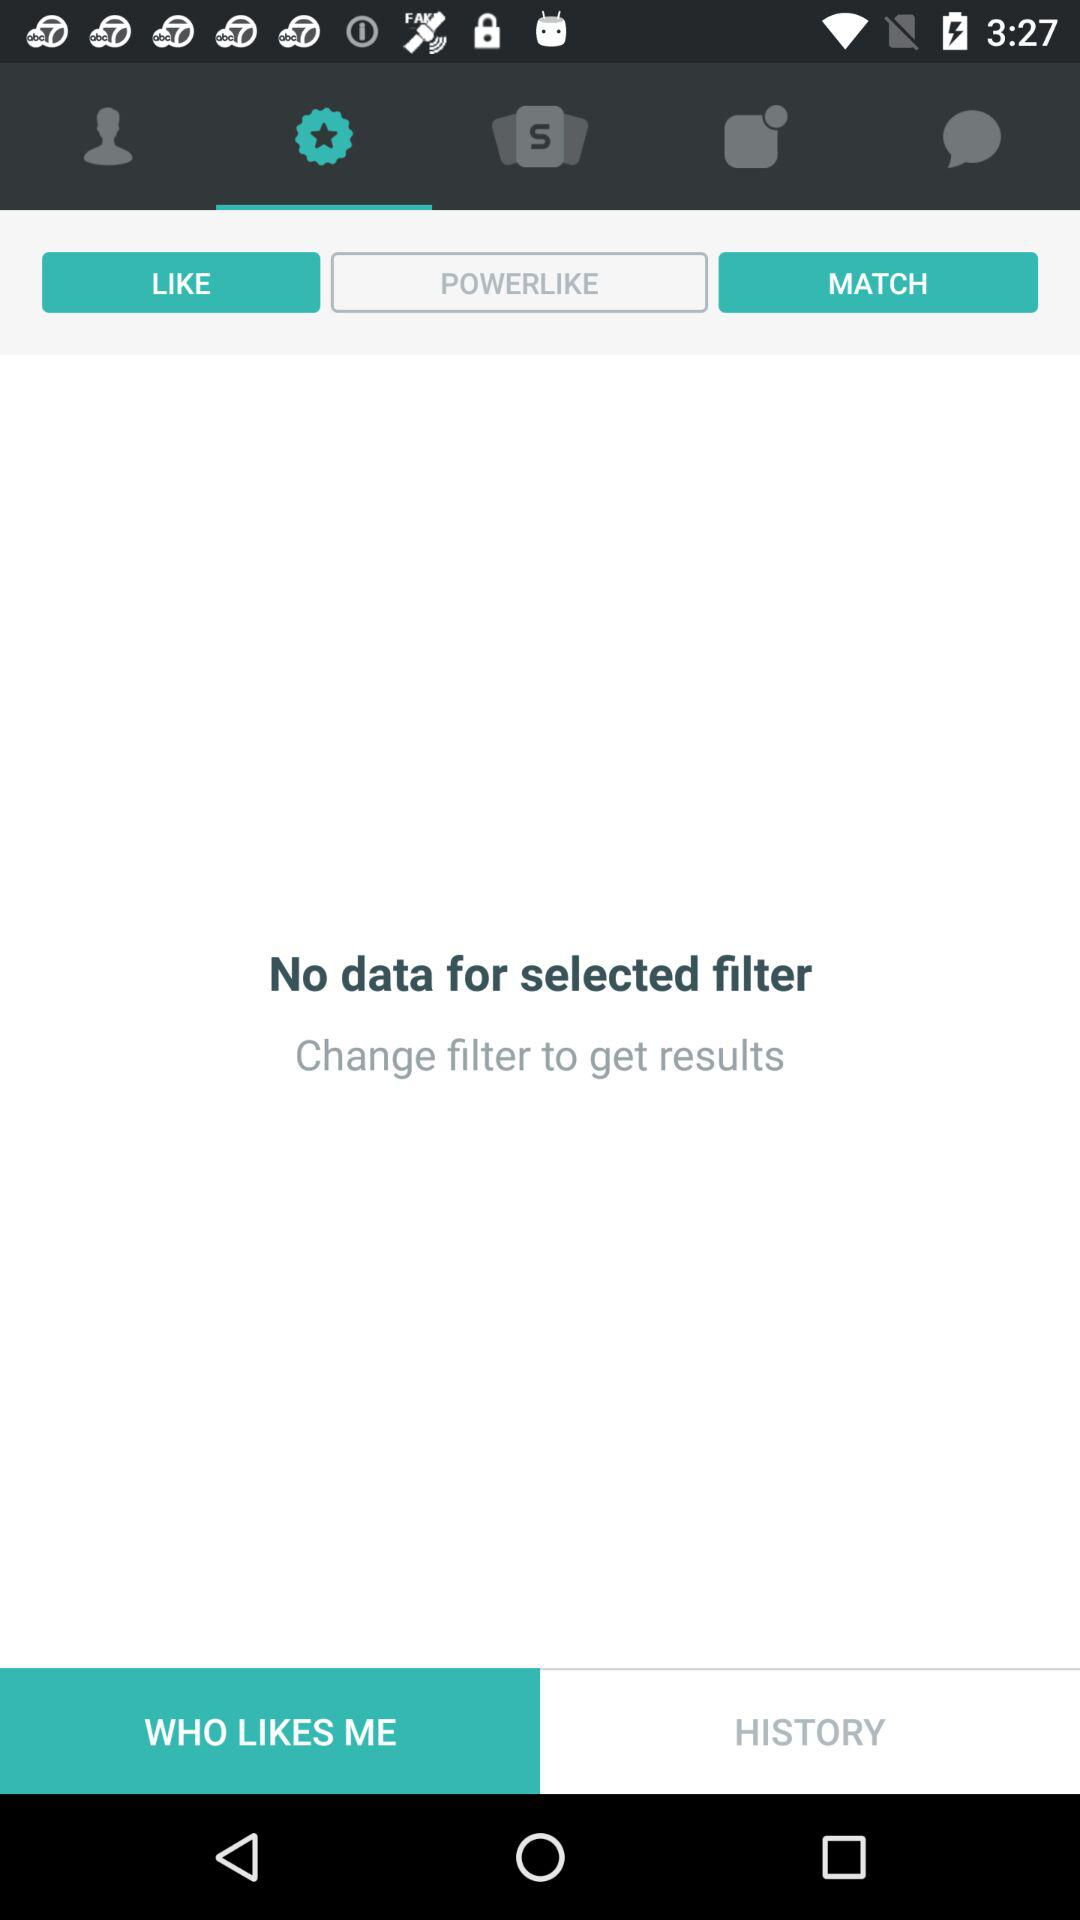Is there any data shown for the selected filter? There is no data shown for the selected filter. 